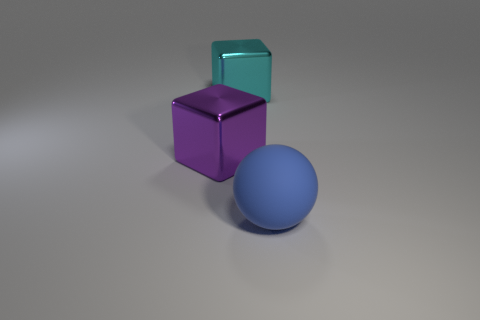Add 2 big blue things. How many objects exist? 5 Subtract all cubes. How many objects are left? 1 Subtract all small blocks. Subtract all metallic cubes. How many objects are left? 1 Add 3 purple metallic objects. How many purple metallic objects are left? 4 Add 2 purple blocks. How many purple blocks exist? 3 Subtract 0 purple spheres. How many objects are left? 3 